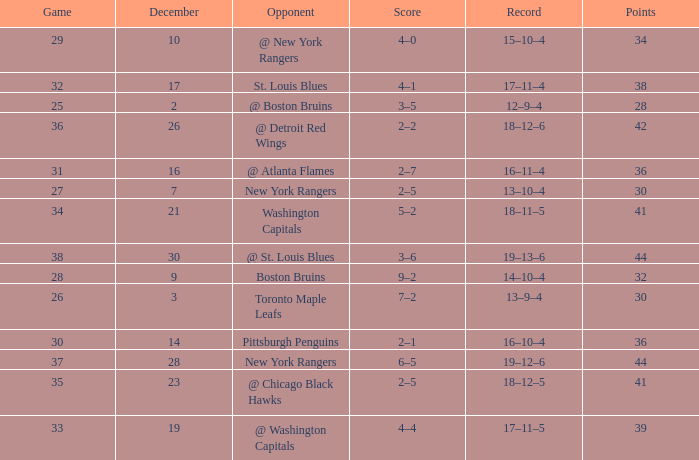Which Game has a Record of 14–10–4, and Points smaller than 32? None. 